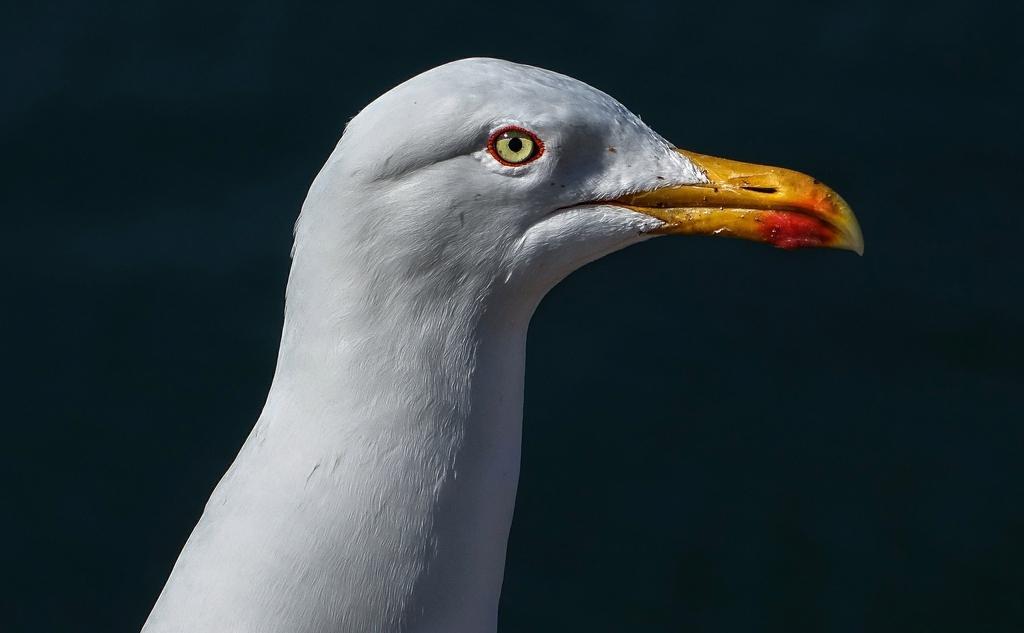Please provide a concise description of this image. In this image I see a bird which is of white in color and it is totally dark in the background. 